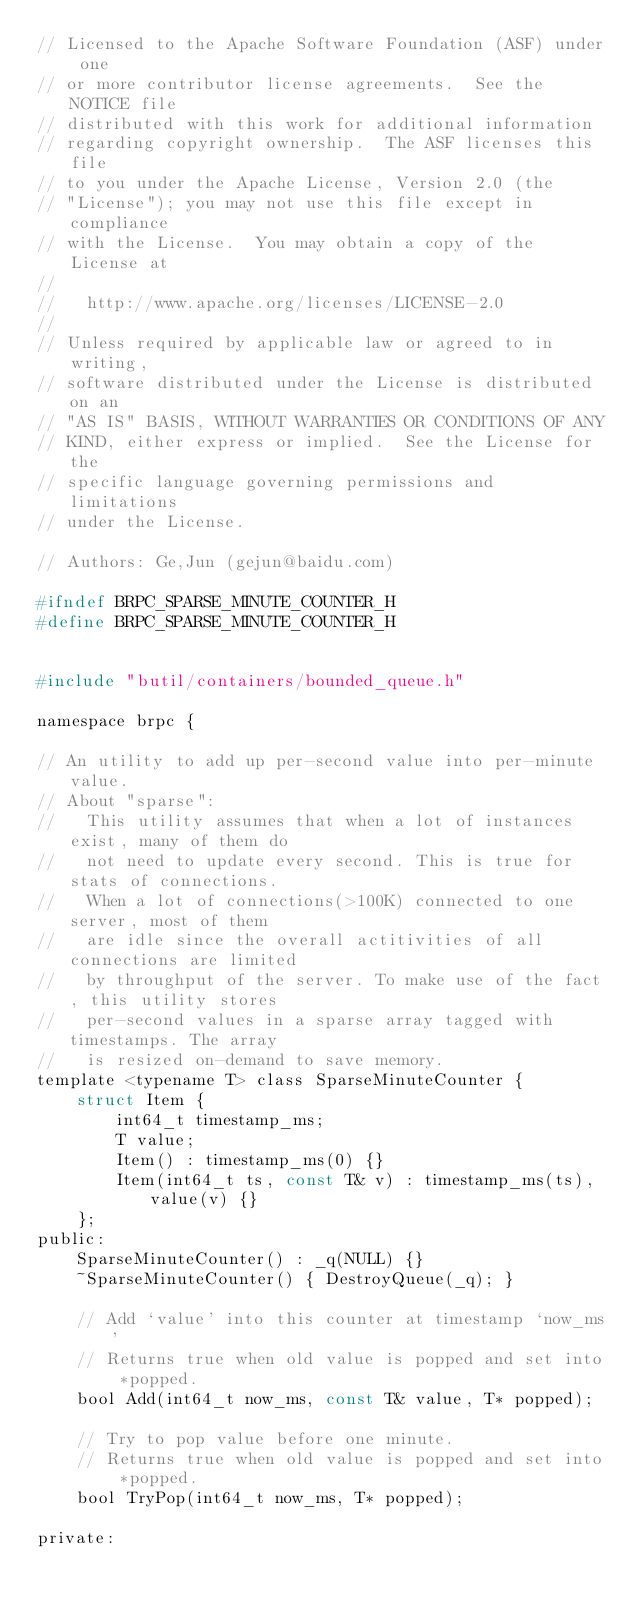<code> <loc_0><loc_0><loc_500><loc_500><_C_>// Licensed to the Apache Software Foundation (ASF) under one
// or more contributor license agreements.  See the NOTICE file
// distributed with this work for additional information
// regarding copyright ownership.  The ASF licenses this file
// to you under the Apache License, Version 2.0 (the
// "License"); you may not use this file except in compliance
// with the License.  You may obtain a copy of the License at
//
//   http://www.apache.org/licenses/LICENSE-2.0
//
// Unless required by applicable law or agreed to in writing,
// software distributed under the License is distributed on an
// "AS IS" BASIS, WITHOUT WARRANTIES OR CONDITIONS OF ANY
// KIND, either express or implied.  See the License for the
// specific language governing permissions and limitations
// under the License.

// Authors: Ge,Jun (gejun@baidu.com)

#ifndef BRPC_SPARSE_MINUTE_COUNTER_H
#define BRPC_SPARSE_MINUTE_COUNTER_H


#include "butil/containers/bounded_queue.h"

namespace brpc {

// An utility to add up per-second value into per-minute value.
// About "sparse":
//   This utility assumes that when a lot of instances exist, many of them do
//   not need to update every second. This is true for stats of connections.
//   When a lot of connections(>100K) connected to one server, most of them
//   are idle since the overall actitivities of all connections are limited
//   by throughput of the server. To make use of the fact, this utility stores
//   per-second values in a sparse array tagged with timestamps. The array
//   is resized on-demand to save memory.
template <typename T> class SparseMinuteCounter {
    struct Item {
        int64_t timestamp_ms;
        T value;
        Item() : timestamp_ms(0) {}
        Item(int64_t ts, const T& v) : timestamp_ms(ts), value(v) {}
    };
public:
    SparseMinuteCounter() : _q(NULL) {}
    ~SparseMinuteCounter() { DestroyQueue(_q); }

    // Add `value' into this counter at timestamp `now_ms'
    // Returns true when old value is popped and set into *popped.
    bool Add(int64_t now_ms, const T& value, T* popped);
    
    // Try to pop value before one minute.
    // Returns true when old value is popped and set into *popped.
    bool TryPop(int64_t now_ms, T* popped);

private:</code> 